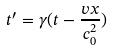Convert formula to latex. <formula><loc_0><loc_0><loc_500><loc_500>t ^ { \prime } = \gamma ( t - \frac { v x } { c _ { 0 } ^ { 2 } } )</formula> 